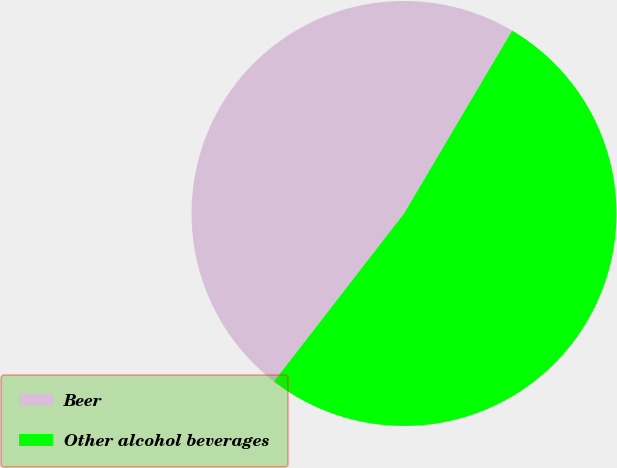Convert chart to OTSL. <chart><loc_0><loc_0><loc_500><loc_500><pie_chart><fcel>Beer<fcel>Other alcohol beverages<nl><fcel>48.0%<fcel>52.0%<nl></chart> 